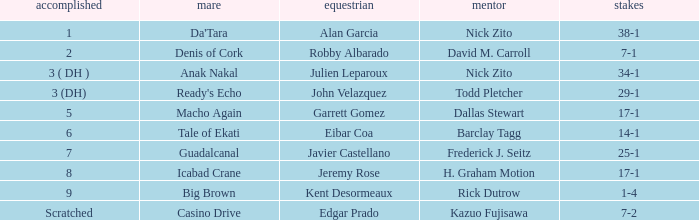Which Horse finished in 8? Icabad Crane. 